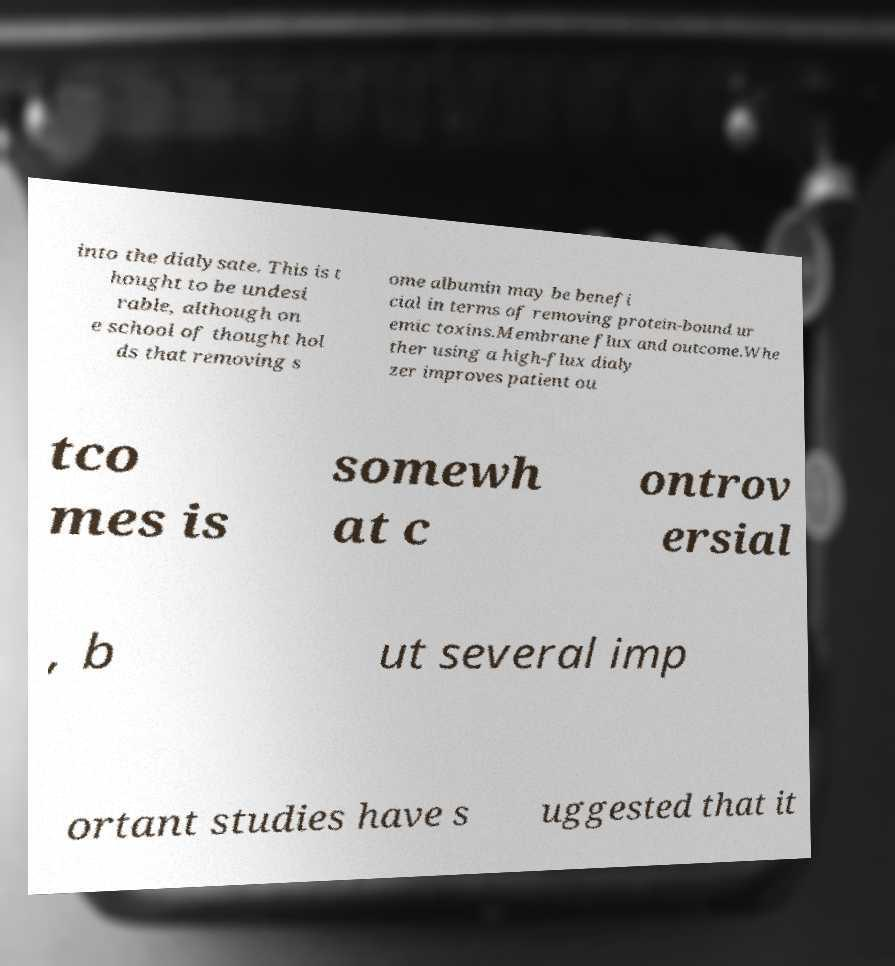Please identify and transcribe the text found in this image. into the dialysate. This is t hought to be undesi rable, although on e school of thought hol ds that removing s ome albumin may be benefi cial in terms of removing protein-bound ur emic toxins.Membrane flux and outcome.Whe ther using a high-flux dialy zer improves patient ou tco mes is somewh at c ontrov ersial , b ut several imp ortant studies have s uggested that it 